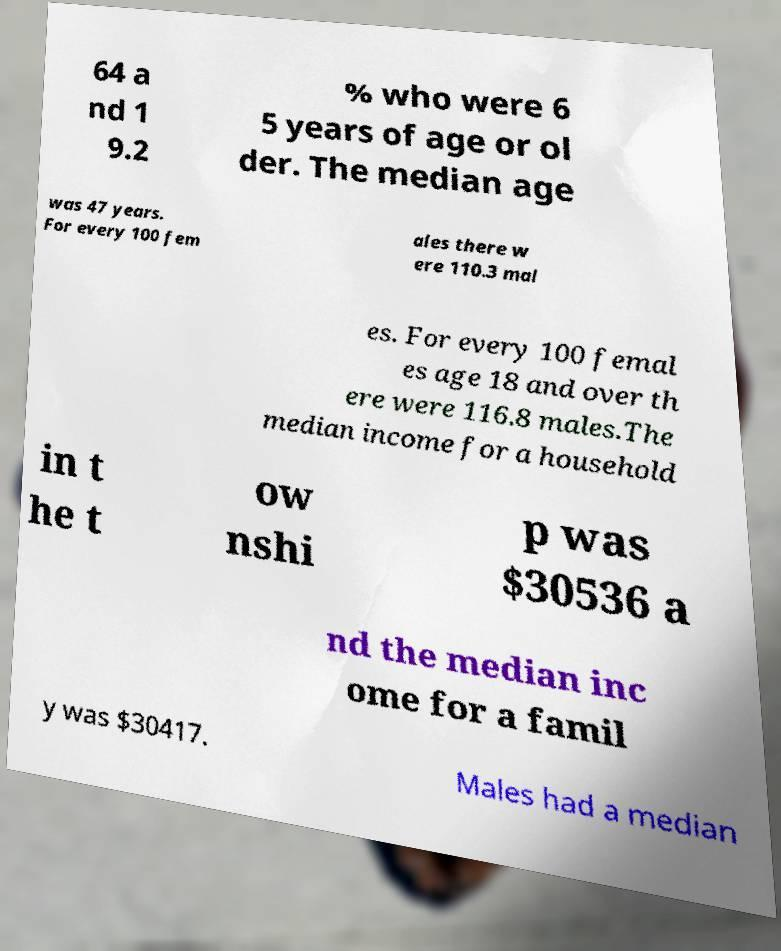Can you read and provide the text displayed in the image?This photo seems to have some interesting text. Can you extract and type it out for me? 64 a nd 1 9.2 % who were 6 5 years of age or ol der. The median age was 47 years. For every 100 fem ales there w ere 110.3 mal es. For every 100 femal es age 18 and over th ere were 116.8 males.The median income for a household in t he t ow nshi p was $30536 a nd the median inc ome for a famil y was $30417. Males had a median 